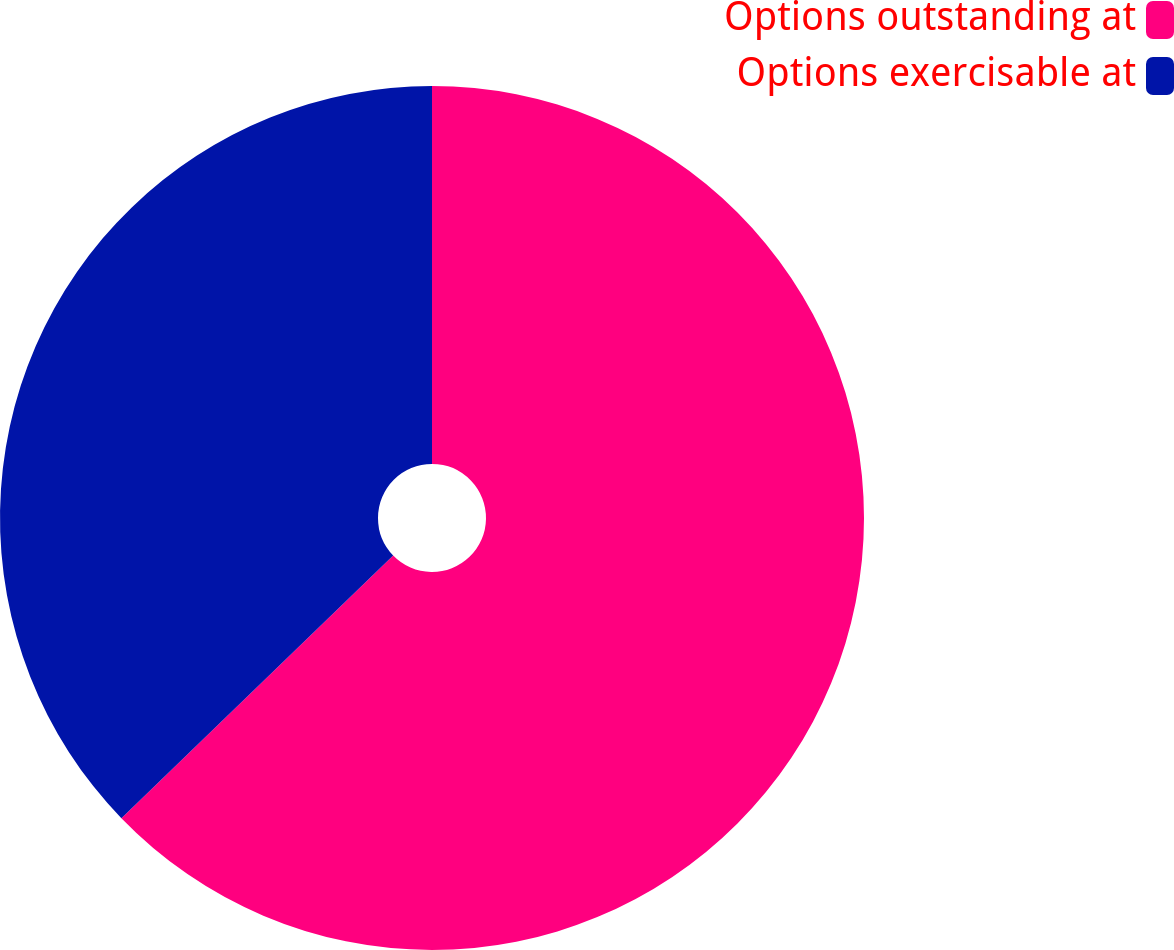Convert chart to OTSL. <chart><loc_0><loc_0><loc_500><loc_500><pie_chart><fcel>Options outstanding at<fcel>Options exercisable at<nl><fcel>62.77%<fcel>37.23%<nl></chart> 